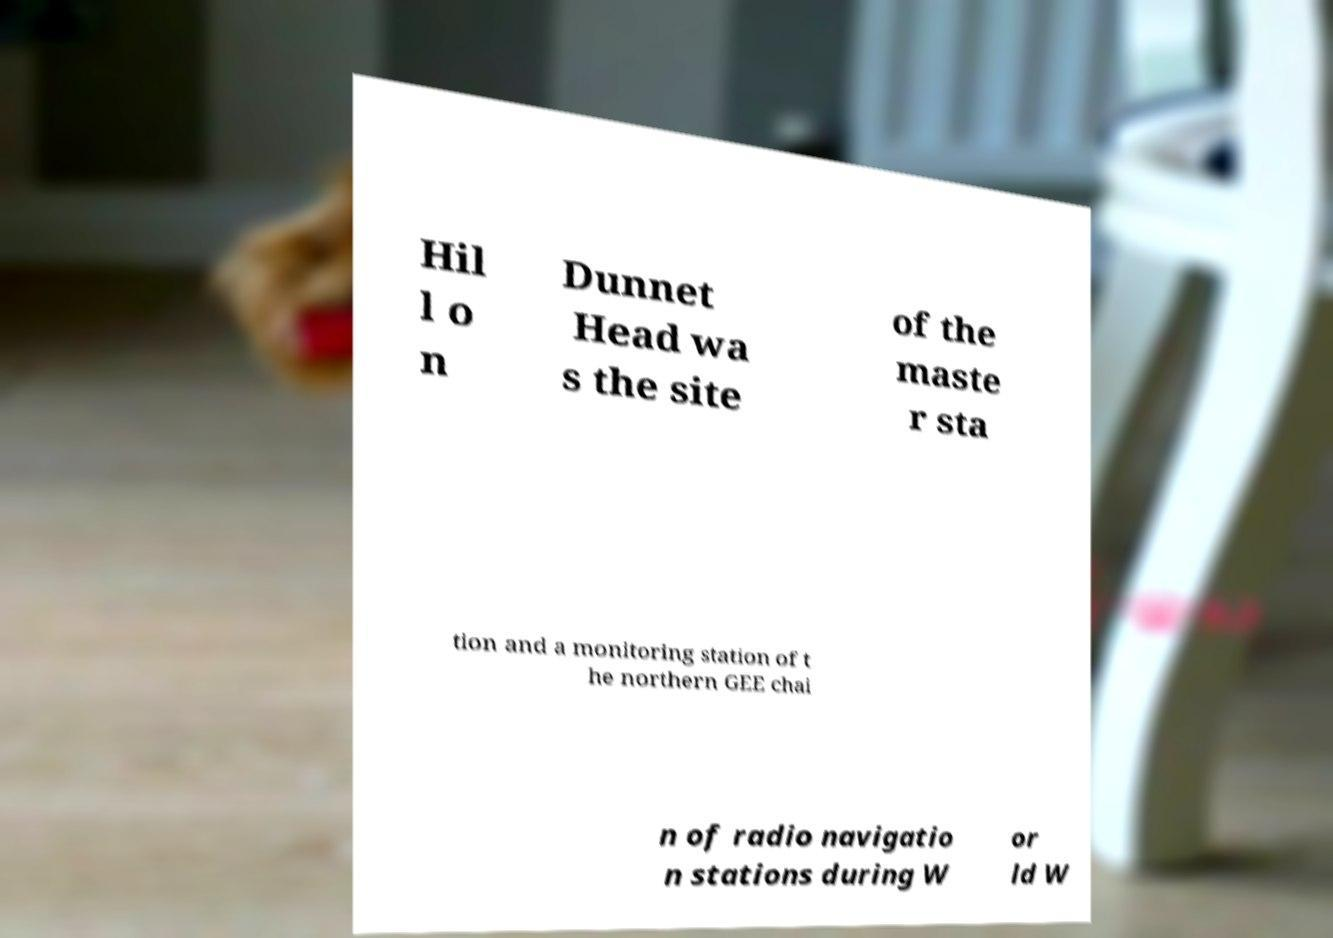I need the written content from this picture converted into text. Can you do that? Hil l o n Dunnet Head wa s the site of the maste r sta tion and a monitoring station of t he northern GEE chai n of radio navigatio n stations during W or ld W 